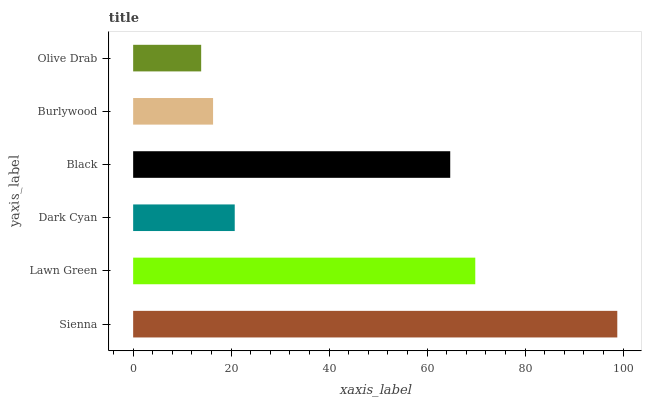Is Olive Drab the minimum?
Answer yes or no. Yes. Is Sienna the maximum?
Answer yes or no. Yes. Is Lawn Green the minimum?
Answer yes or no. No. Is Lawn Green the maximum?
Answer yes or no. No. Is Sienna greater than Lawn Green?
Answer yes or no. Yes. Is Lawn Green less than Sienna?
Answer yes or no. Yes. Is Lawn Green greater than Sienna?
Answer yes or no. No. Is Sienna less than Lawn Green?
Answer yes or no. No. Is Black the high median?
Answer yes or no. Yes. Is Dark Cyan the low median?
Answer yes or no. Yes. Is Lawn Green the high median?
Answer yes or no. No. Is Black the low median?
Answer yes or no. No. 